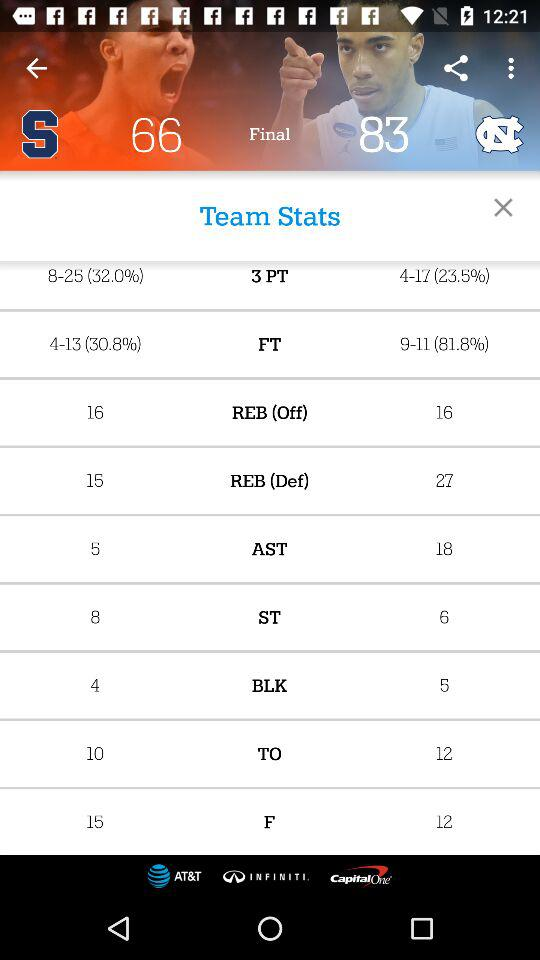What is the number of shots blocked by the "North Carolina Tar Heels"? The number of blocked shots is 5. 